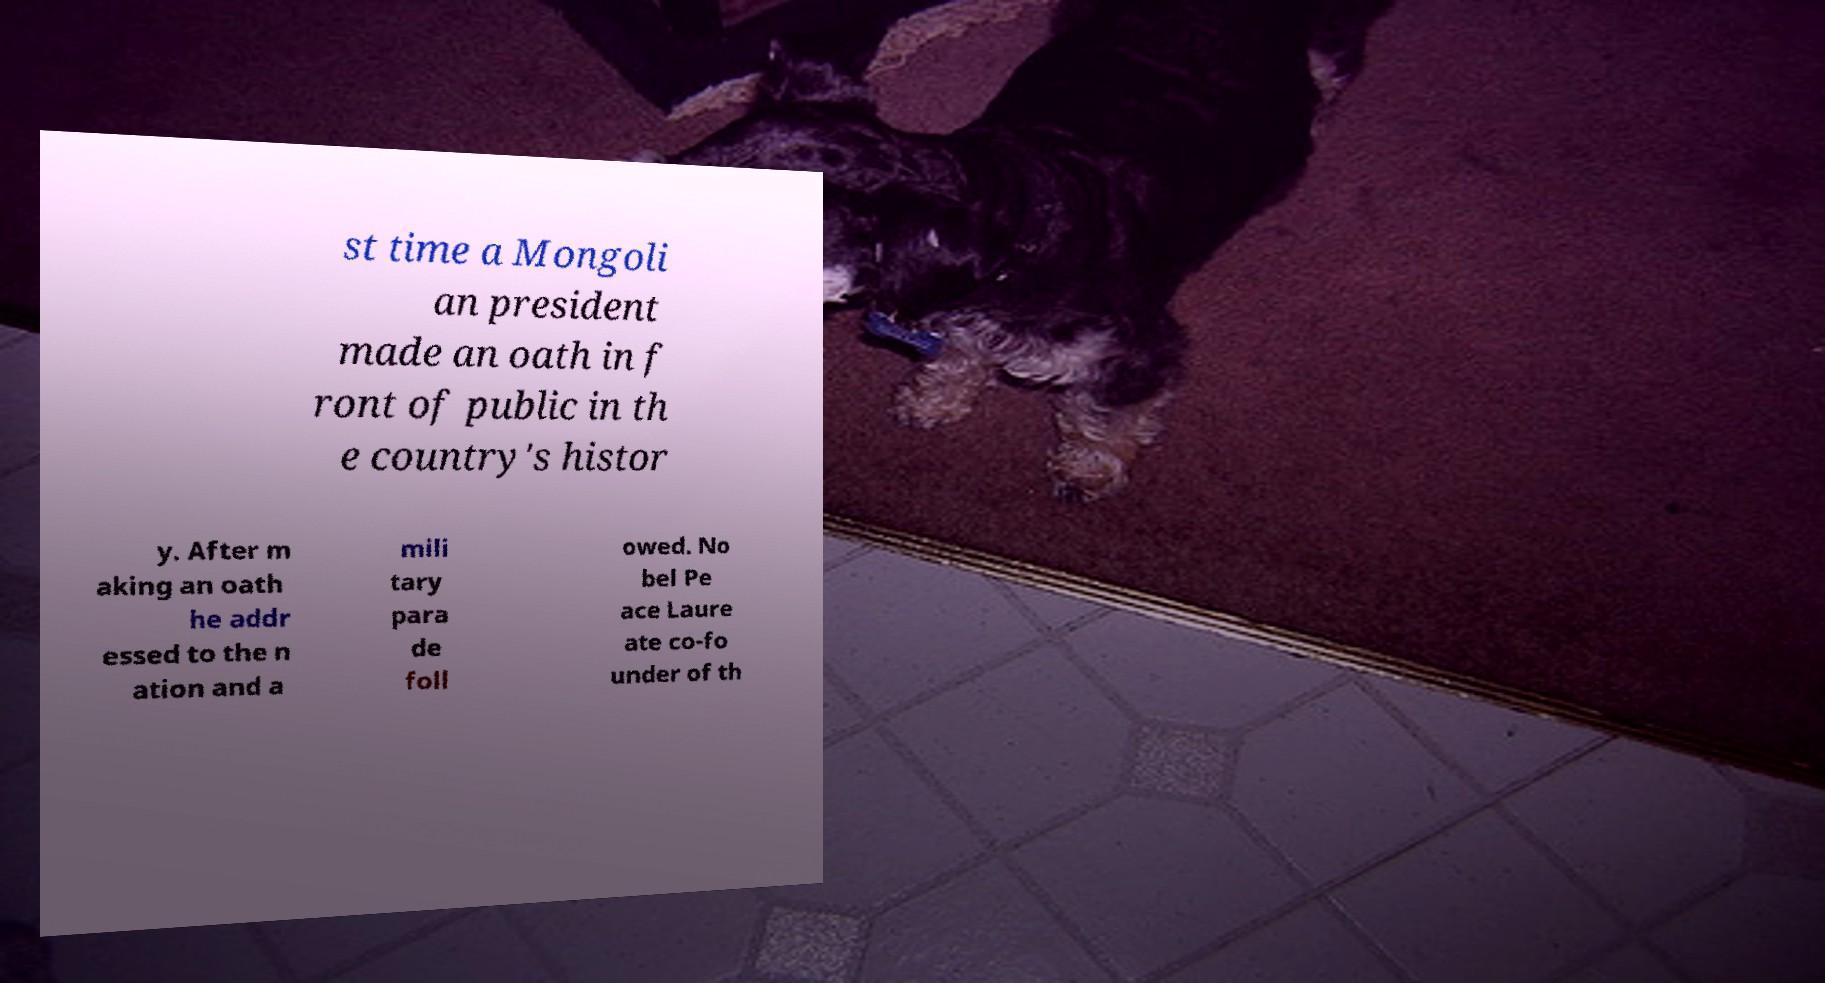For documentation purposes, I need the text within this image transcribed. Could you provide that? st time a Mongoli an president made an oath in f ront of public in th e country's histor y. After m aking an oath he addr essed to the n ation and a mili tary para de foll owed. No bel Pe ace Laure ate co-fo under of th 